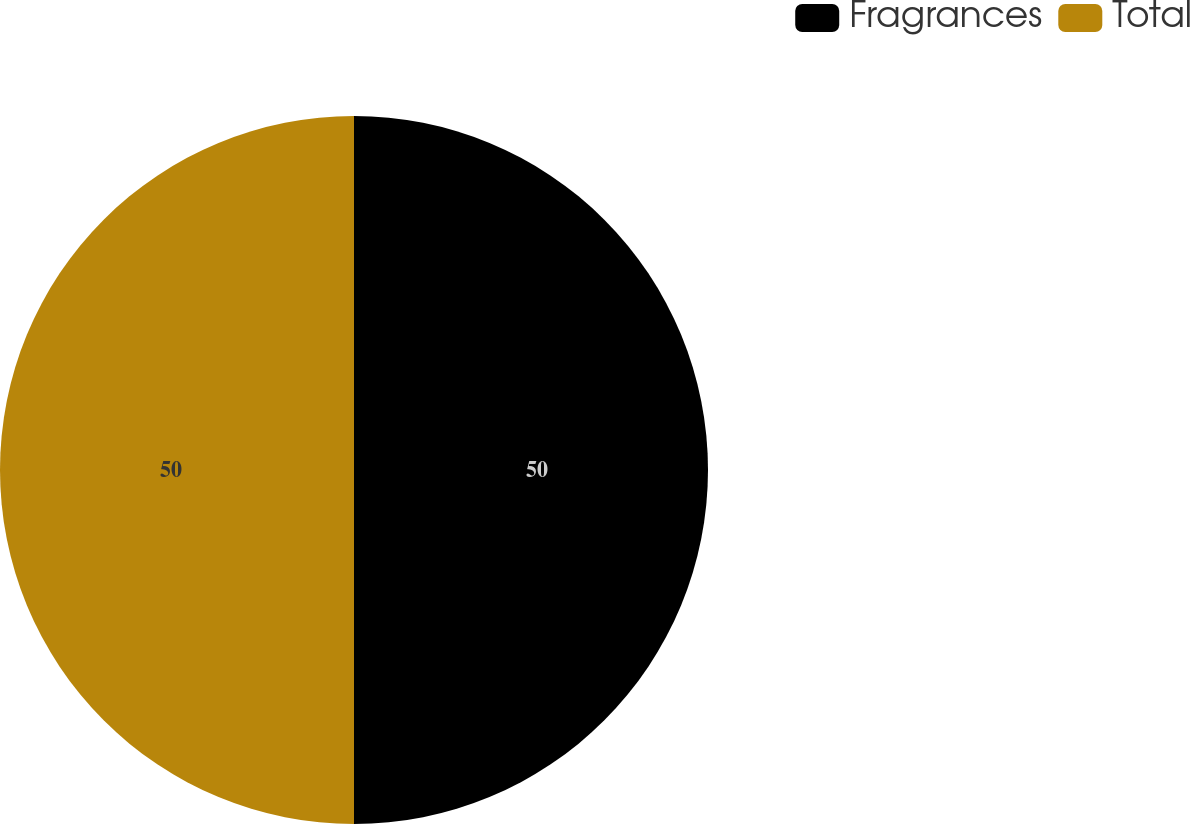Convert chart. <chart><loc_0><loc_0><loc_500><loc_500><pie_chart><fcel>Fragrances<fcel>Total<nl><fcel>50.0%<fcel>50.0%<nl></chart> 